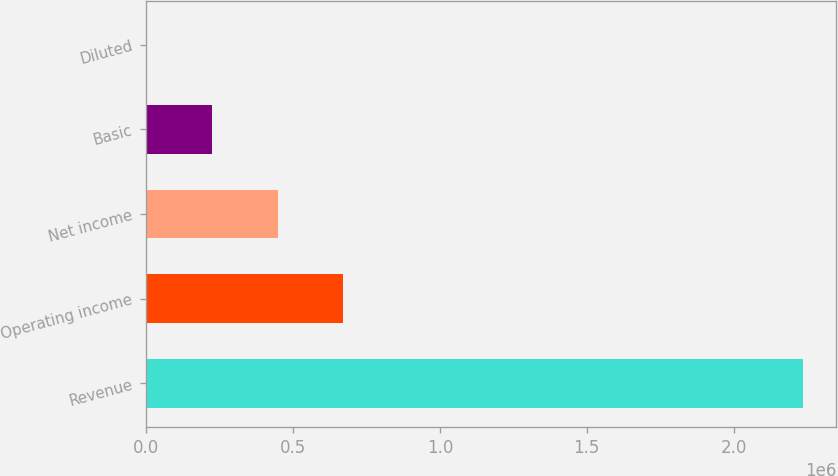<chart> <loc_0><loc_0><loc_500><loc_500><bar_chart><fcel>Revenue<fcel>Operating income<fcel>Net income<fcel>Basic<fcel>Diluted<nl><fcel>2.23759e+06<fcel>671276<fcel>447518<fcel>223759<fcel>0.7<nl></chart> 